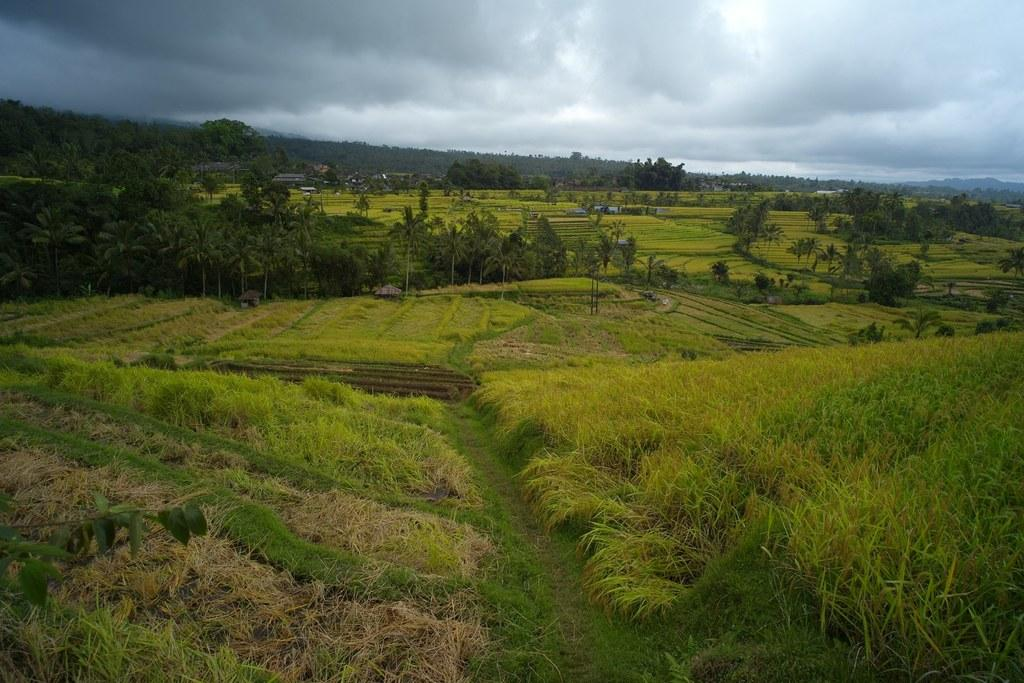What type of vegetation can be seen in the image? There are trees in the image. What type of structures are present in the image? There are houses in the image. What is the color of the grass in the image? The grass in the image is green and brown in color. What colors can be seen in the sky in the image? The sky is blue and white in color. How many mint leaves can be seen on the trees in the image? There are no mint leaves present on the trees in the image; it only features trees with leaves. What type of creatures are stopping traffic in the image? There is no traffic or lizards present in the image. 